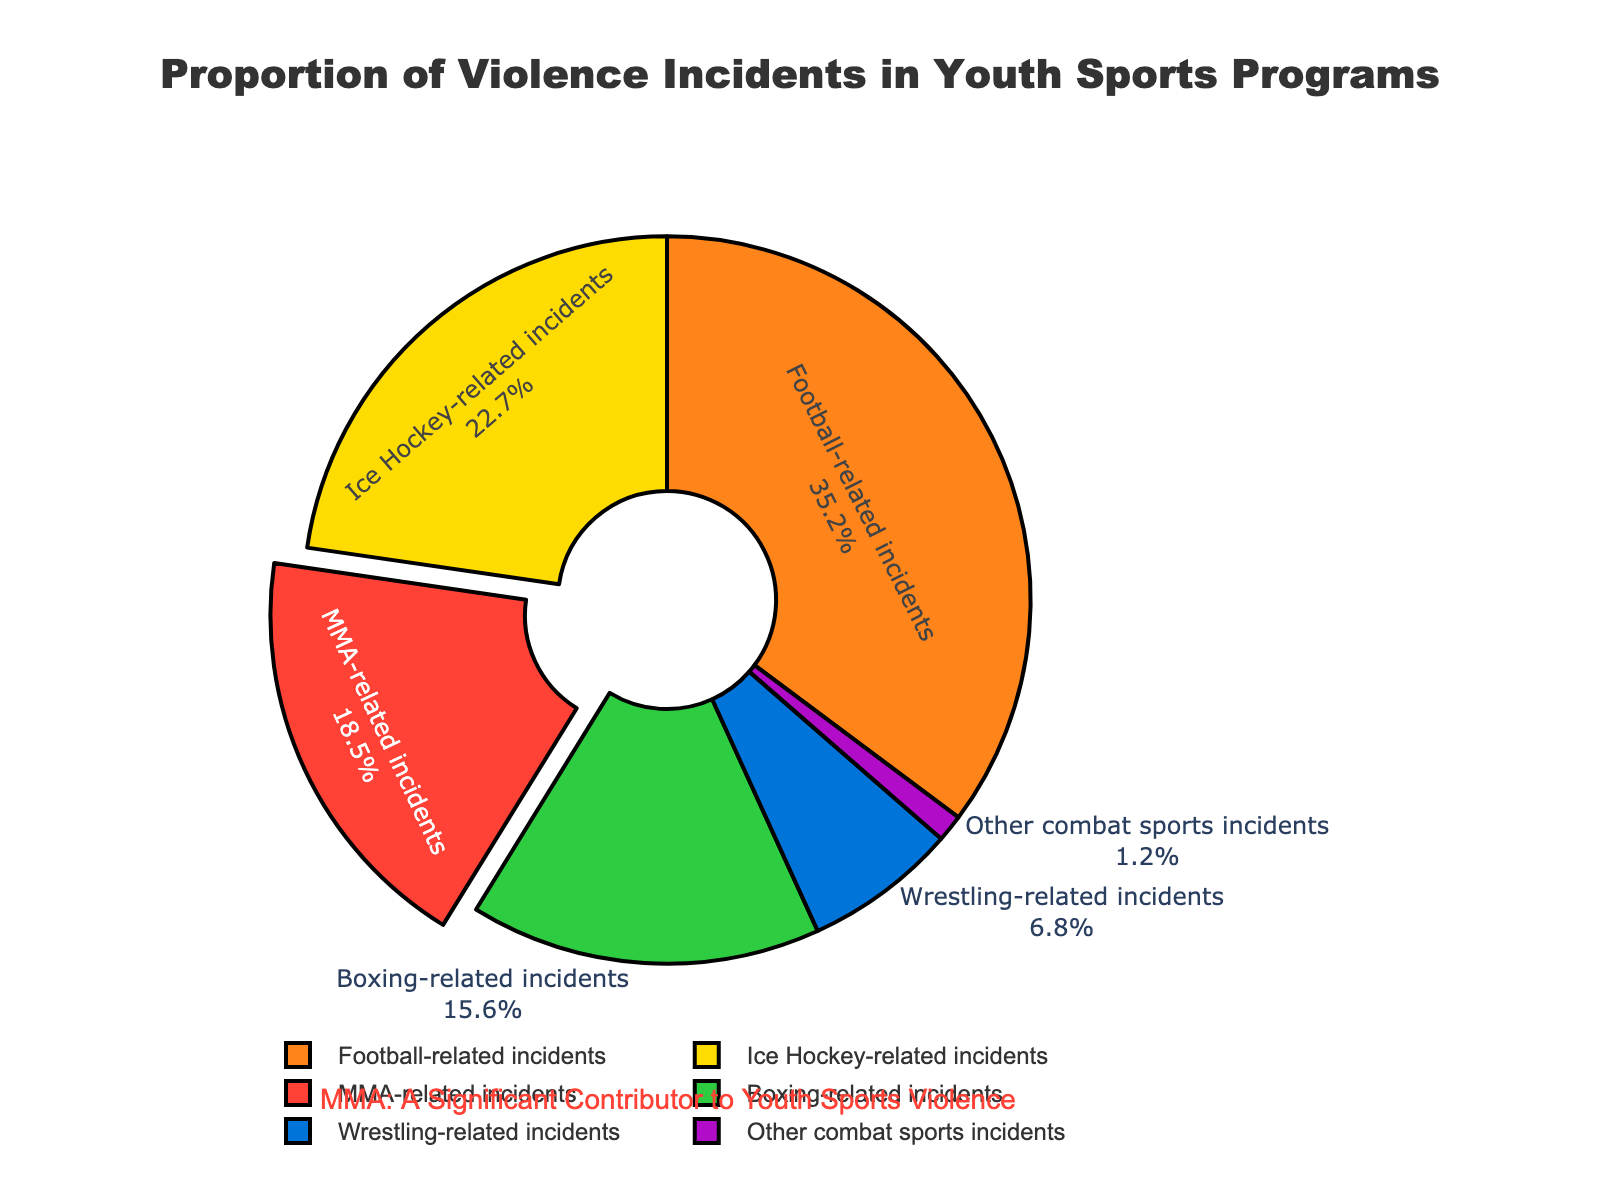Which sport has the highest percentage of violence incidents? The pie chart shows the percentages of violence incidents for various sports. From the labels, football-related incidents have the highest percentage at 35.2%.
Answer: Football-related incidents Which sport has the least percentage of violence incidents? According to the chart, the section representing other combat sports incidents has the smallest slice, with a percentage of 1.2%.
Answer: Other combat sports incidents What is the combined percentage of violence incidents for MMA-related and Ice Hockey-related incidents? The pie chart shows that MMA-related incidents are 18.5% and Ice Hockey-related incidents are 22.7%. Adding these together, 18.5% + 22.7% = 41.2%.
Answer: 41.2% How does the percentage of MMA-related incidents compare to that of boxing-related incidents? The pie chart indicates that MMA-related incidents are 18.5%, while boxing-related incidents are 15.6%. Thus, MMA-related incidents have a higher percentage.
Answer: MMA-related incidents have a higher percentage What proportion of the total incidents does wrestling-related violence represent? The wrestling-related incidents make up 6.8% of the total incidents seen in the chart.
Answer: 6.8% Which sport has a lower percentage of violence incidents: Ice Hockey or Boxing? According to the pie chart, Ice Hockey incidents are at 22.7% and Boxing incidents are at 15.6%. Therefore, Boxing has a lower percentage.
Answer: Boxing Among MMA-related, Football-related, and Ice Hockey-related incidents, which is the largest contributor to violence? From the chart, Football-related incidents are 35.2%, Ice Hockey-related incidents are 22.7%, and MMA-related incidents are 18.5%. Football-related incidents are the largest contributor.
Answer: Football-related incidents Sum the percentage of all sports except MMA-related incidents. To find this, sum the percentages of all other sports: Football (35.2%) + Ice Hockey (22.7%) + Boxing (15.6%) + Wrestling (6.8%) + Other combat sports (1.2%). Therefore, 35.2% + 22.7% + 15.6% + 6.8% + 1.2% = 81.5%.
Answer: 81.5% What is the difference in percentage between wrestling-related and other combat sports incidents? The chart shows that wrestling-related incidents are 6.8% and other combat sports incidents are 1.2%. The difference is 6.8% - 1.2% = 5.6%.
Answer: 5.6% Which section of the pie chart is highlighted or pulled out? The slice representing MMA-related incidents is visually pulled out from the pie chart, indicating it is highlighted.
Answer: MMA-related incidents are pulled out 